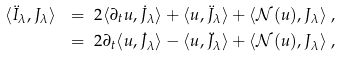<formula> <loc_0><loc_0><loc_500><loc_500>\langle \ddot { I } _ { \lambda } , J _ { \lambda } \rangle \ & = \ 2 \langle \partial _ { t } u , \dot { J } _ { \lambda } \rangle + \langle u , \ddot { J } _ { \lambda } \rangle + \langle \mathcal { N } ( u ) , J _ { \lambda } \rangle \ , \\ & = \ 2 \partial _ { t } \langle u , \dot { J } _ { \lambda } \rangle - \langle u , \ddot { J } _ { \lambda } \rangle + \langle \mathcal { N } ( u ) , J _ { \lambda } \rangle \ ,</formula> 